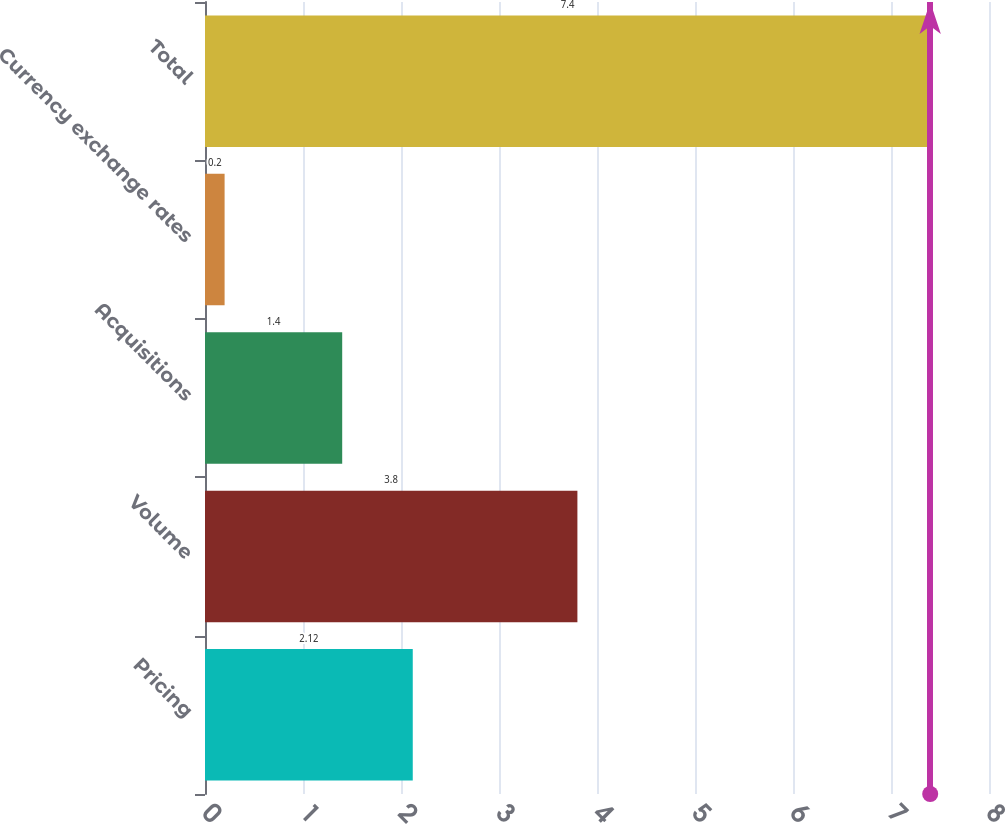<chart> <loc_0><loc_0><loc_500><loc_500><bar_chart><fcel>Pricing<fcel>Volume<fcel>Acquisitions<fcel>Currency exchange rates<fcel>Total<nl><fcel>2.12<fcel>3.8<fcel>1.4<fcel>0.2<fcel>7.4<nl></chart> 